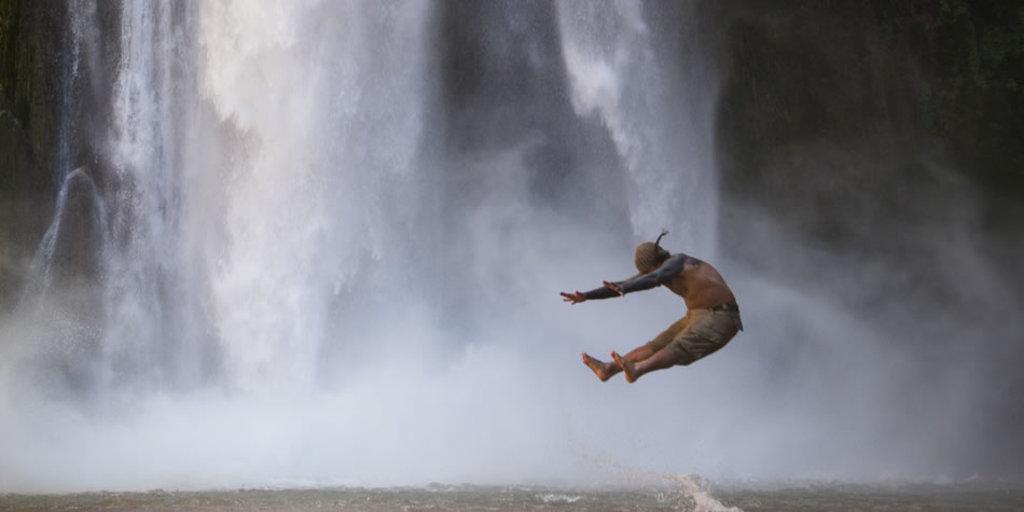Could you give a brief overview of what you see in this image? In this picture we can see a person is in air and in the background we can see water. 